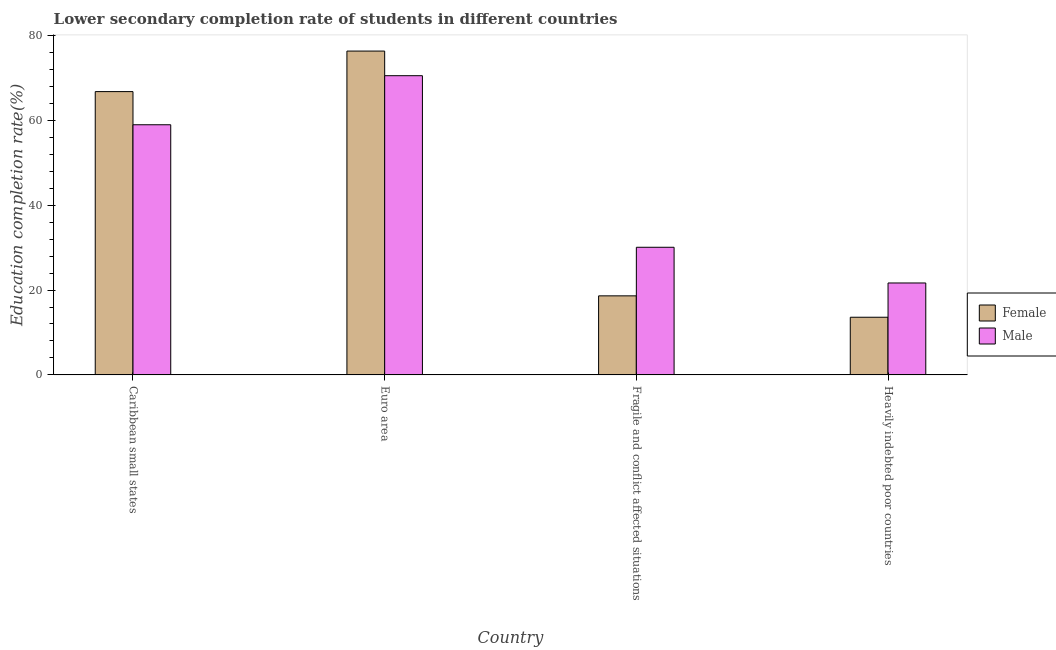How many bars are there on the 2nd tick from the left?
Offer a terse response. 2. What is the education completion rate of male students in Heavily indebted poor countries?
Your response must be concise. 21.67. Across all countries, what is the maximum education completion rate of female students?
Offer a terse response. 76.32. Across all countries, what is the minimum education completion rate of female students?
Your response must be concise. 13.59. In which country was the education completion rate of female students maximum?
Your answer should be compact. Euro area. In which country was the education completion rate of male students minimum?
Make the answer very short. Heavily indebted poor countries. What is the total education completion rate of female students in the graph?
Make the answer very short. 175.3. What is the difference between the education completion rate of female students in Caribbean small states and that in Fragile and conflict affected situations?
Your answer should be very brief. 48.13. What is the difference between the education completion rate of female students in Euro area and the education completion rate of male students in Fragile and conflict affected situations?
Provide a short and direct response. 46.24. What is the average education completion rate of female students per country?
Your answer should be very brief. 43.83. What is the difference between the education completion rate of female students and education completion rate of male students in Euro area?
Your answer should be very brief. 5.8. What is the ratio of the education completion rate of male students in Caribbean small states to that in Heavily indebted poor countries?
Your answer should be very brief. 2.72. Is the education completion rate of male students in Euro area less than that in Fragile and conflict affected situations?
Provide a short and direct response. No. Is the difference between the education completion rate of male students in Euro area and Fragile and conflict affected situations greater than the difference between the education completion rate of female students in Euro area and Fragile and conflict affected situations?
Offer a terse response. No. What is the difference between the highest and the second highest education completion rate of female students?
Your answer should be compact. 9.55. What is the difference between the highest and the lowest education completion rate of female students?
Your answer should be compact. 62.73. What does the 1st bar from the right in Heavily indebted poor countries represents?
Offer a very short reply. Male. How many bars are there?
Provide a succinct answer. 8. Does the graph contain any zero values?
Your response must be concise. No. Where does the legend appear in the graph?
Provide a succinct answer. Center right. How are the legend labels stacked?
Your answer should be compact. Vertical. What is the title of the graph?
Your response must be concise. Lower secondary completion rate of students in different countries. Does "Central government" appear as one of the legend labels in the graph?
Your response must be concise. No. What is the label or title of the X-axis?
Ensure brevity in your answer.  Country. What is the label or title of the Y-axis?
Keep it short and to the point. Education completion rate(%). What is the Education completion rate(%) in Female in Caribbean small states?
Your answer should be very brief. 66.76. What is the Education completion rate(%) of Male in Caribbean small states?
Keep it short and to the point. 58.95. What is the Education completion rate(%) in Female in Euro area?
Provide a short and direct response. 76.32. What is the Education completion rate(%) of Male in Euro area?
Keep it short and to the point. 70.51. What is the Education completion rate(%) in Female in Fragile and conflict affected situations?
Ensure brevity in your answer.  18.63. What is the Education completion rate(%) in Male in Fragile and conflict affected situations?
Offer a very short reply. 30.08. What is the Education completion rate(%) in Female in Heavily indebted poor countries?
Give a very brief answer. 13.59. What is the Education completion rate(%) in Male in Heavily indebted poor countries?
Provide a short and direct response. 21.67. Across all countries, what is the maximum Education completion rate(%) in Female?
Provide a short and direct response. 76.32. Across all countries, what is the maximum Education completion rate(%) of Male?
Provide a succinct answer. 70.51. Across all countries, what is the minimum Education completion rate(%) of Female?
Provide a succinct answer. 13.59. Across all countries, what is the minimum Education completion rate(%) of Male?
Offer a very short reply. 21.67. What is the total Education completion rate(%) in Female in the graph?
Keep it short and to the point. 175.3. What is the total Education completion rate(%) in Male in the graph?
Offer a very short reply. 181.21. What is the difference between the Education completion rate(%) of Female in Caribbean small states and that in Euro area?
Provide a succinct answer. -9.55. What is the difference between the Education completion rate(%) in Male in Caribbean small states and that in Euro area?
Provide a short and direct response. -11.56. What is the difference between the Education completion rate(%) in Female in Caribbean small states and that in Fragile and conflict affected situations?
Your answer should be compact. 48.13. What is the difference between the Education completion rate(%) in Male in Caribbean small states and that in Fragile and conflict affected situations?
Make the answer very short. 28.87. What is the difference between the Education completion rate(%) in Female in Caribbean small states and that in Heavily indebted poor countries?
Ensure brevity in your answer.  53.17. What is the difference between the Education completion rate(%) in Male in Caribbean small states and that in Heavily indebted poor countries?
Offer a very short reply. 37.28. What is the difference between the Education completion rate(%) in Female in Euro area and that in Fragile and conflict affected situations?
Offer a terse response. 57.68. What is the difference between the Education completion rate(%) of Male in Euro area and that in Fragile and conflict affected situations?
Make the answer very short. 40.43. What is the difference between the Education completion rate(%) of Female in Euro area and that in Heavily indebted poor countries?
Your answer should be very brief. 62.73. What is the difference between the Education completion rate(%) of Male in Euro area and that in Heavily indebted poor countries?
Your response must be concise. 48.85. What is the difference between the Education completion rate(%) in Female in Fragile and conflict affected situations and that in Heavily indebted poor countries?
Ensure brevity in your answer.  5.04. What is the difference between the Education completion rate(%) in Male in Fragile and conflict affected situations and that in Heavily indebted poor countries?
Offer a terse response. 8.41. What is the difference between the Education completion rate(%) of Female in Caribbean small states and the Education completion rate(%) of Male in Euro area?
Your answer should be very brief. -3.75. What is the difference between the Education completion rate(%) of Female in Caribbean small states and the Education completion rate(%) of Male in Fragile and conflict affected situations?
Offer a terse response. 36.68. What is the difference between the Education completion rate(%) of Female in Caribbean small states and the Education completion rate(%) of Male in Heavily indebted poor countries?
Give a very brief answer. 45.1. What is the difference between the Education completion rate(%) in Female in Euro area and the Education completion rate(%) in Male in Fragile and conflict affected situations?
Your response must be concise. 46.24. What is the difference between the Education completion rate(%) of Female in Euro area and the Education completion rate(%) of Male in Heavily indebted poor countries?
Give a very brief answer. 54.65. What is the difference between the Education completion rate(%) in Female in Fragile and conflict affected situations and the Education completion rate(%) in Male in Heavily indebted poor countries?
Provide a succinct answer. -3.03. What is the average Education completion rate(%) in Female per country?
Keep it short and to the point. 43.83. What is the average Education completion rate(%) in Male per country?
Your response must be concise. 45.3. What is the difference between the Education completion rate(%) in Female and Education completion rate(%) in Male in Caribbean small states?
Ensure brevity in your answer.  7.81. What is the difference between the Education completion rate(%) of Female and Education completion rate(%) of Male in Euro area?
Keep it short and to the point. 5.8. What is the difference between the Education completion rate(%) of Female and Education completion rate(%) of Male in Fragile and conflict affected situations?
Provide a short and direct response. -11.45. What is the difference between the Education completion rate(%) in Female and Education completion rate(%) in Male in Heavily indebted poor countries?
Your response must be concise. -8.08. What is the ratio of the Education completion rate(%) of Female in Caribbean small states to that in Euro area?
Offer a very short reply. 0.87. What is the ratio of the Education completion rate(%) in Male in Caribbean small states to that in Euro area?
Make the answer very short. 0.84. What is the ratio of the Education completion rate(%) of Female in Caribbean small states to that in Fragile and conflict affected situations?
Offer a terse response. 3.58. What is the ratio of the Education completion rate(%) of Male in Caribbean small states to that in Fragile and conflict affected situations?
Your response must be concise. 1.96. What is the ratio of the Education completion rate(%) in Female in Caribbean small states to that in Heavily indebted poor countries?
Your answer should be compact. 4.91. What is the ratio of the Education completion rate(%) of Male in Caribbean small states to that in Heavily indebted poor countries?
Your answer should be very brief. 2.72. What is the ratio of the Education completion rate(%) in Female in Euro area to that in Fragile and conflict affected situations?
Make the answer very short. 4.1. What is the ratio of the Education completion rate(%) in Male in Euro area to that in Fragile and conflict affected situations?
Your answer should be compact. 2.34. What is the ratio of the Education completion rate(%) in Female in Euro area to that in Heavily indebted poor countries?
Give a very brief answer. 5.62. What is the ratio of the Education completion rate(%) of Male in Euro area to that in Heavily indebted poor countries?
Provide a succinct answer. 3.25. What is the ratio of the Education completion rate(%) in Female in Fragile and conflict affected situations to that in Heavily indebted poor countries?
Give a very brief answer. 1.37. What is the ratio of the Education completion rate(%) in Male in Fragile and conflict affected situations to that in Heavily indebted poor countries?
Your response must be concise. 1.39. What is the difference between the highest and the second highest Education completion rate(%) in Female?
Provide a succinct answer. 9.55. What is the difference between the highest and the second highest Education completion rate(%) in Male?
Your answer should be compact. 11.56. What is the difference between the highest and the lowest Education completion rate(%) in Female?
Provide a succinct answer. 62.73. What is the difference between the highest and the lowest Education completion rate(%) of Male?
Provide a succinct answer. 48.85. 